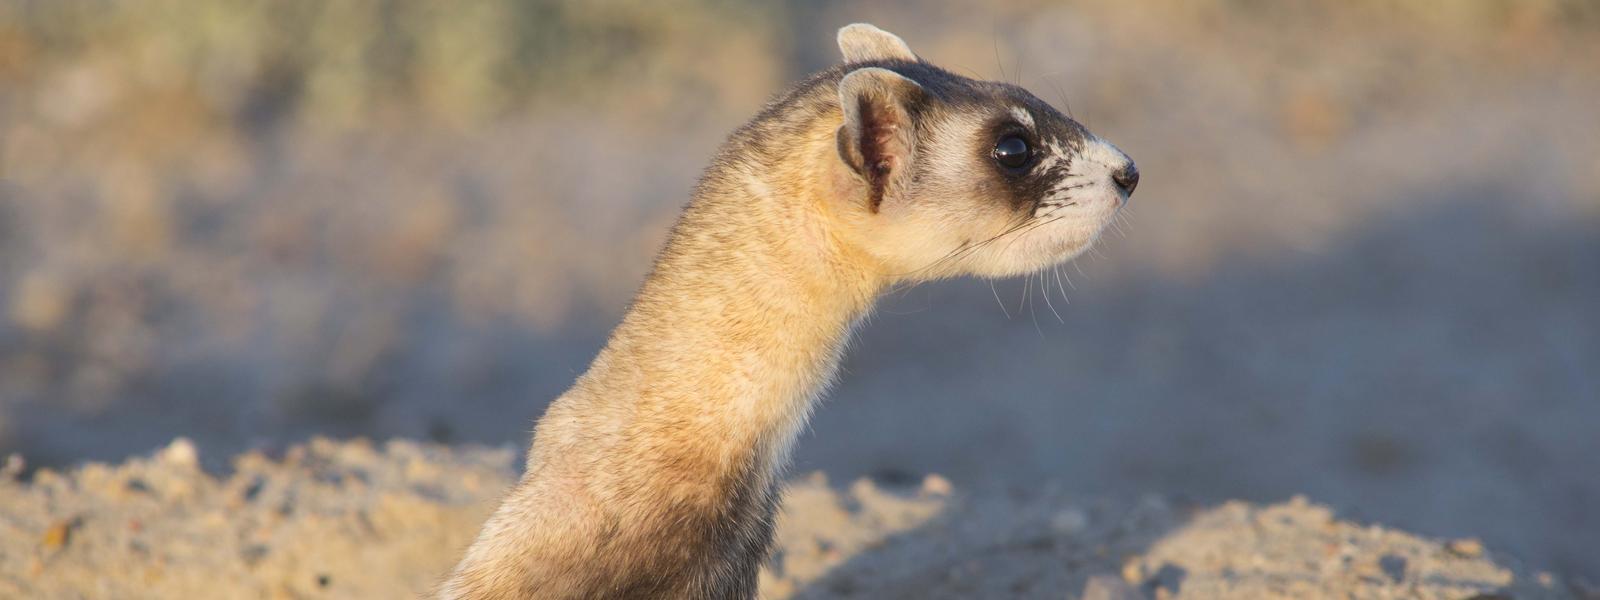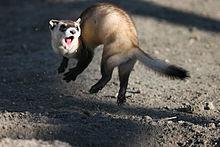The first image is the image on the left, the second image is the image on the right. Examine the images to the left and right. Is the description "A ferret is partially inside of a hole." accurate? Answer yes or no. No. 